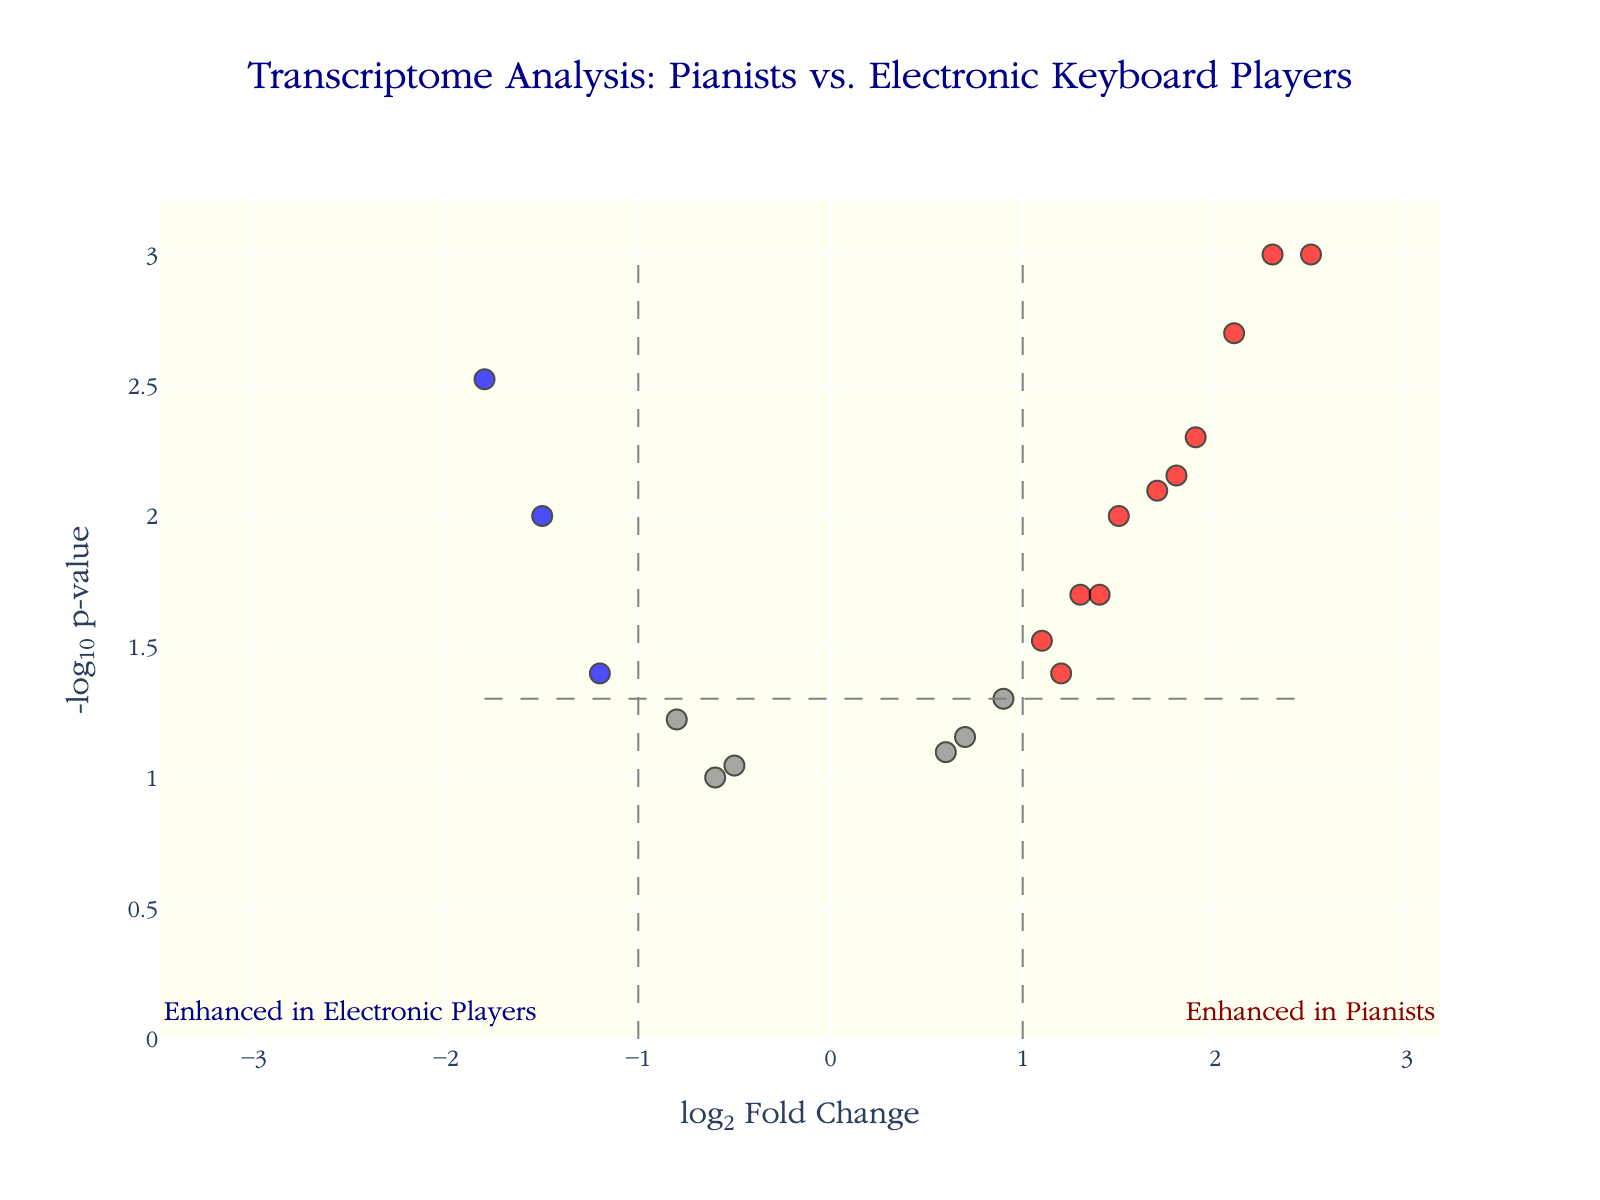What is the title of the plot? The title of the plot is displayed at the top center of the figure and reads "Transcriptome Analysis: Pianists vs. Electronic Keyboard Players."
Answer: Transcriptome Analysis: Pianists vs. Electronic Keyboard Players How many genes show significant differences in expression between pianists and electronic keyboard players? The significant genes are highlighted in either red or blue. There are 9 data points colored distinctly.
Answer: 9 Which gene has the highest log2 fold change value? On the x-axis representing log2 fold change, the highest value corresponds to a point with a hover text showing gene "ACTA1".
Answer: ACTA1 What does a red color data point indicate in this plot? By the color coding design, red color indicates genes with significant differences and a positive log2 fold change, meaning they are more expressed in pianists.
Answer: More expressed in pianists How many genes have a p-value less than 0.05? The threshold for significance is shown by a horizontal grey dashed line at -log10(0.05). Data points above this line indicate p-values less than 0.05. Count these points.
Answer: 13 Which gene is most significantly upregulated in pianists, and what is its associated p-value? The most significant upregulation means the lowest p-value with positive log2 fold change. Hovering over data shows "ACTA1" with p-value 0.001.
Answer: ACTA1, 0.001 Which gene has the most negative log2 fold change? On the x-axis representing log2 fold change, the most negative value corresponds to a point showing gene "MYH2".
Answer: MYH2 What does a blue color data point indicate in the plot? Blue indicates genes with significant differences and a negative log2 fold change, meaning they are more expressed in electronic keyboard players.
Answer: More expressed in electronic keyboard players What does the horizontal dashed line represent? The horizontal dashed line represents the significance threshold for the p-value, specifically -log10(0.05). Points above this line have p-values less than 0.05.
Answer: p-value threshold at 0.05 